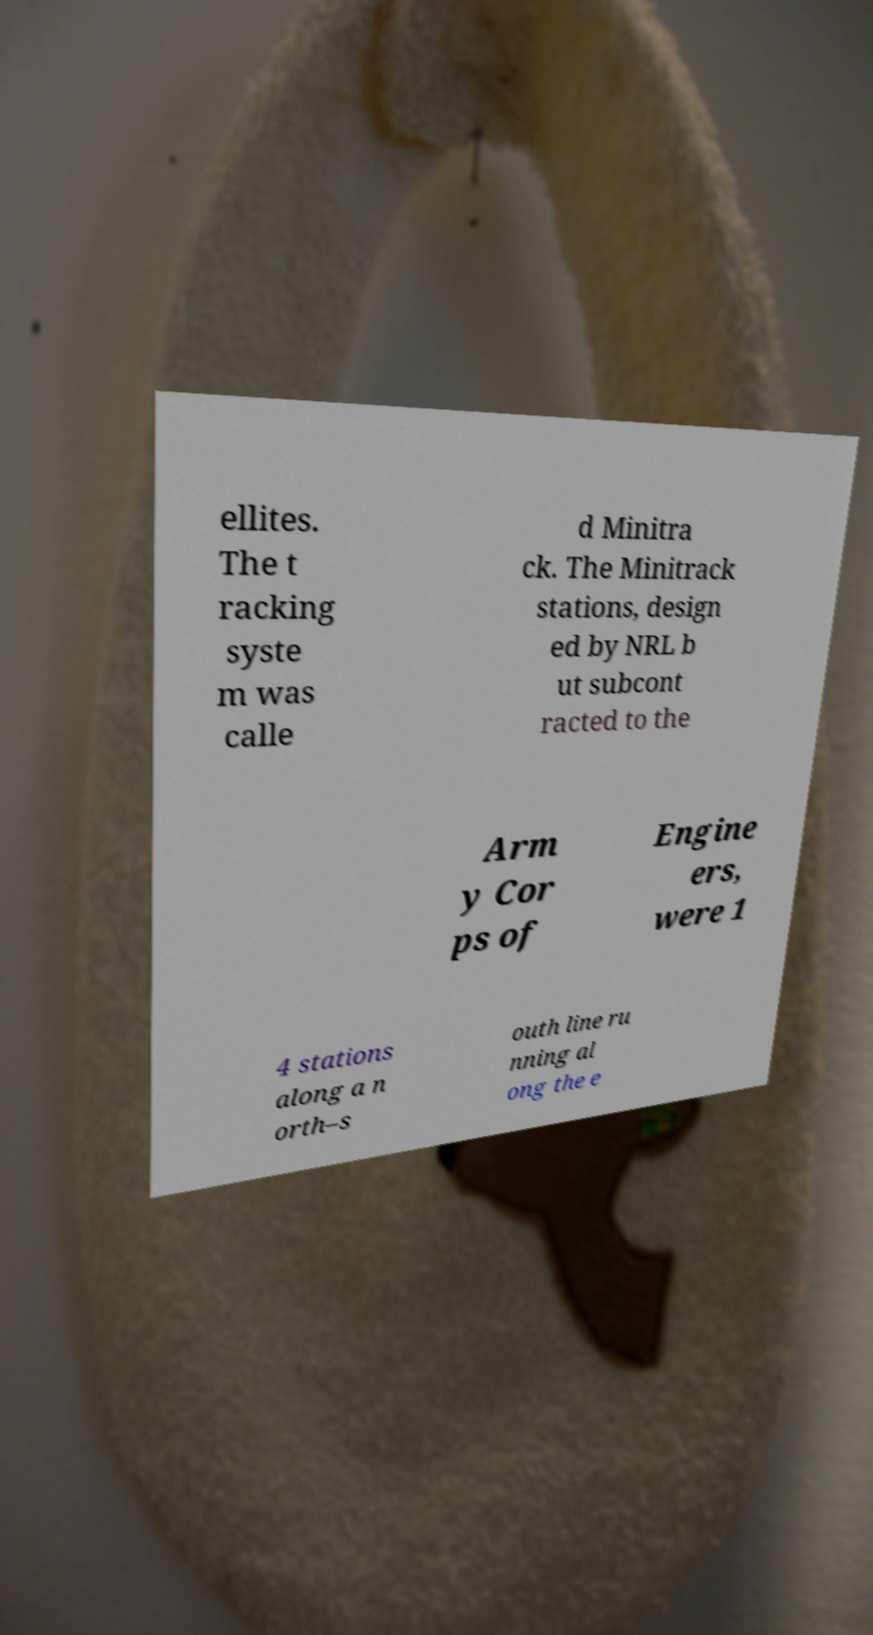Can you read and provide the text displayed in the image?This photo seems to have some interesting text. Can you extract and type it out for me? ellites. The t racking syste m was calle d Minitra ck. The Minitrack stations, design ed by NRL b ut subcont racted to the Arm y Cor ps of Engine ers, were 1 4 stations along a n orth–s outh line ru nning al ong the e 